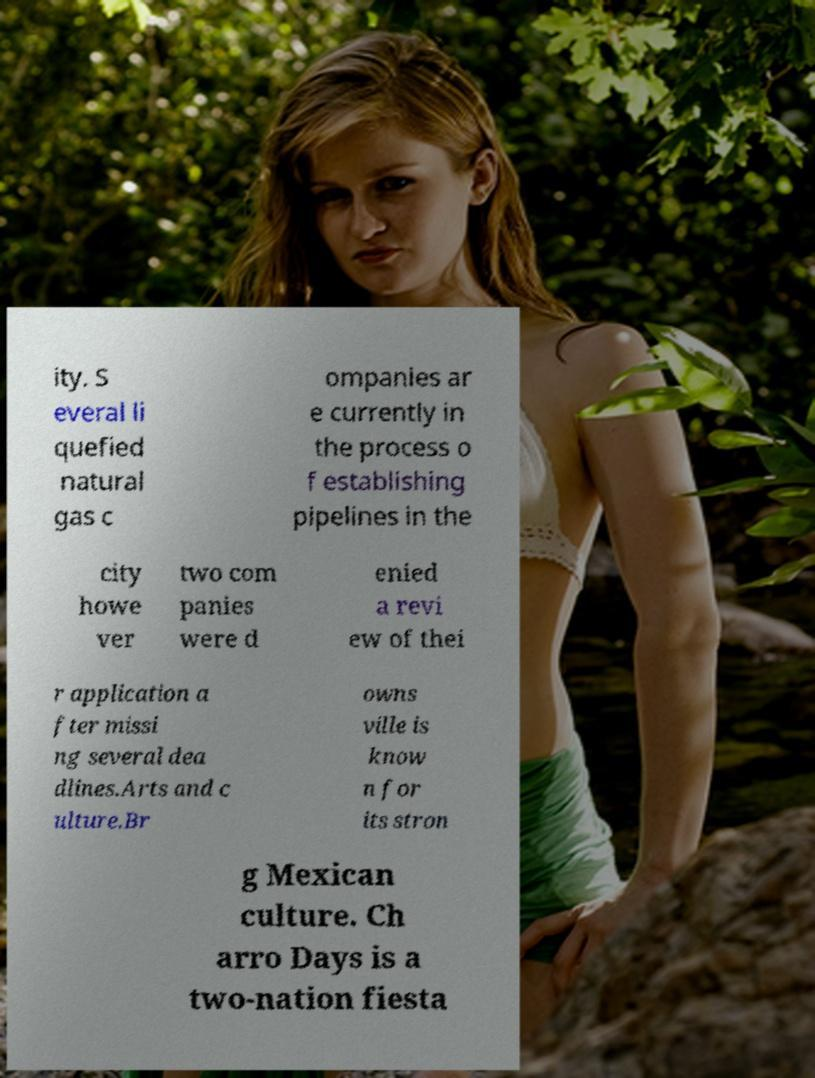Please identify and transcribe the text found in this image. ity. S everal li quefied natural gas c ompanies ar e currently in the process o f establishing pipelines in the city howe ver two com panies were d enied a revi ew of thei r application a fter missi ng several dea dlines.Arts and c ulture.Br owns ville is know n for its stron g Mexican culture. Ch arro Days is a two-nation fiesta 